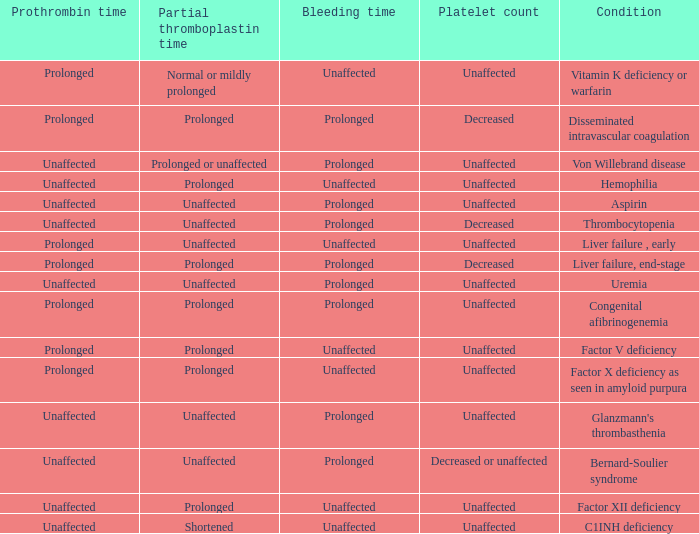Which Condition has an unaffected Prothrombin time and a Bleeding time, and a Partial thromboplastin time of prolonged? Hemophilia, Factor XII deficiency. 